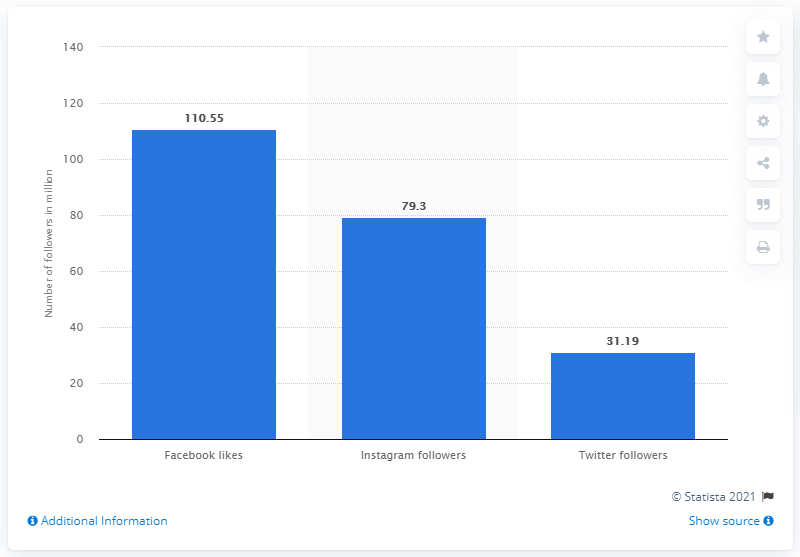Give some essential details in this illustration. In 2019, Barcelona had 110.55 Facebook fans. 